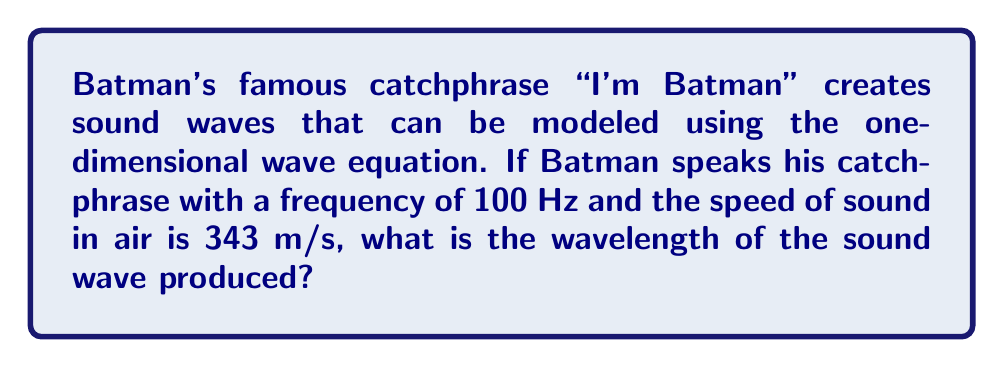What is the answer to this math problem? To solve this problem, we'll use the relationship between wave speed, frequency, and wavelength. This relationship is given by the wave equation:

$$v = f \lambda$$

Where:
$v$ is the wave speed (in m/s)
$f$ is the frequency (in Hz)
$\lambda$ is the wavelength (in m)

Given:
- Frequency, $f = 100$ Hz
- Speed of sound in air, $v = 343$ m/s

Step 1: Rearrange the wave equation to solve for wavelength:
$$\lambda = \frac{v}{f}$$

Step 2: Substitute the known values:
$$\lambda = \frac{343 \text{ m/s}}{100 \text{ Hz}}$$

Step 3: Calculate the wavelength:
$$\lambda = 3.43 \text{ m}$$

Therefore, the wavelength of the sound wave produced by Batman's catchphrase is 3.43 meters.
Answer: 3.43 m 